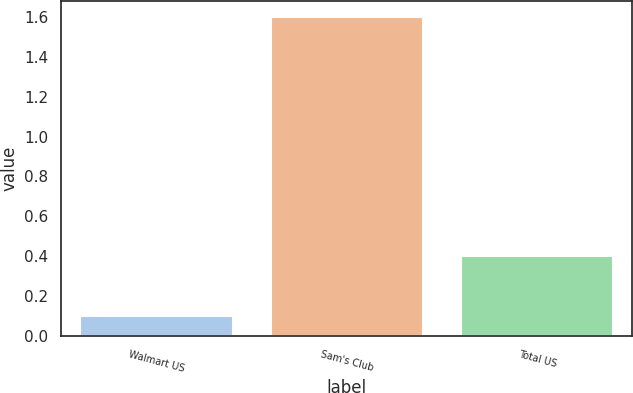Convert chart. <chart><loc_0><loc_0><loc_500><loc_500><bar_chart><fcel>Walmart US<fcel>Sam's Club<fcel>Total US<nl><fcel>0.1<fcel>1.6<fcel>0.4<nl></chart> 